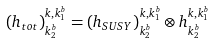Convert formula to latex. <formula><loc_0><loc_0><loc_500><loc_500>( h _ { t o t } ) ^ { k , k ^ { b } _ { 1 } } _ { k ^ { b } _ { 2 } } = ( h _ { S U S Y } ) ^ { k , k ^ { b } _ { 1 } } _ { k ^ { b } _ { 2 } } \otimes h ^ { k , k ^ { b } _ { 1 } } _ { k ^ { b } _ { 2 } }</formula> 